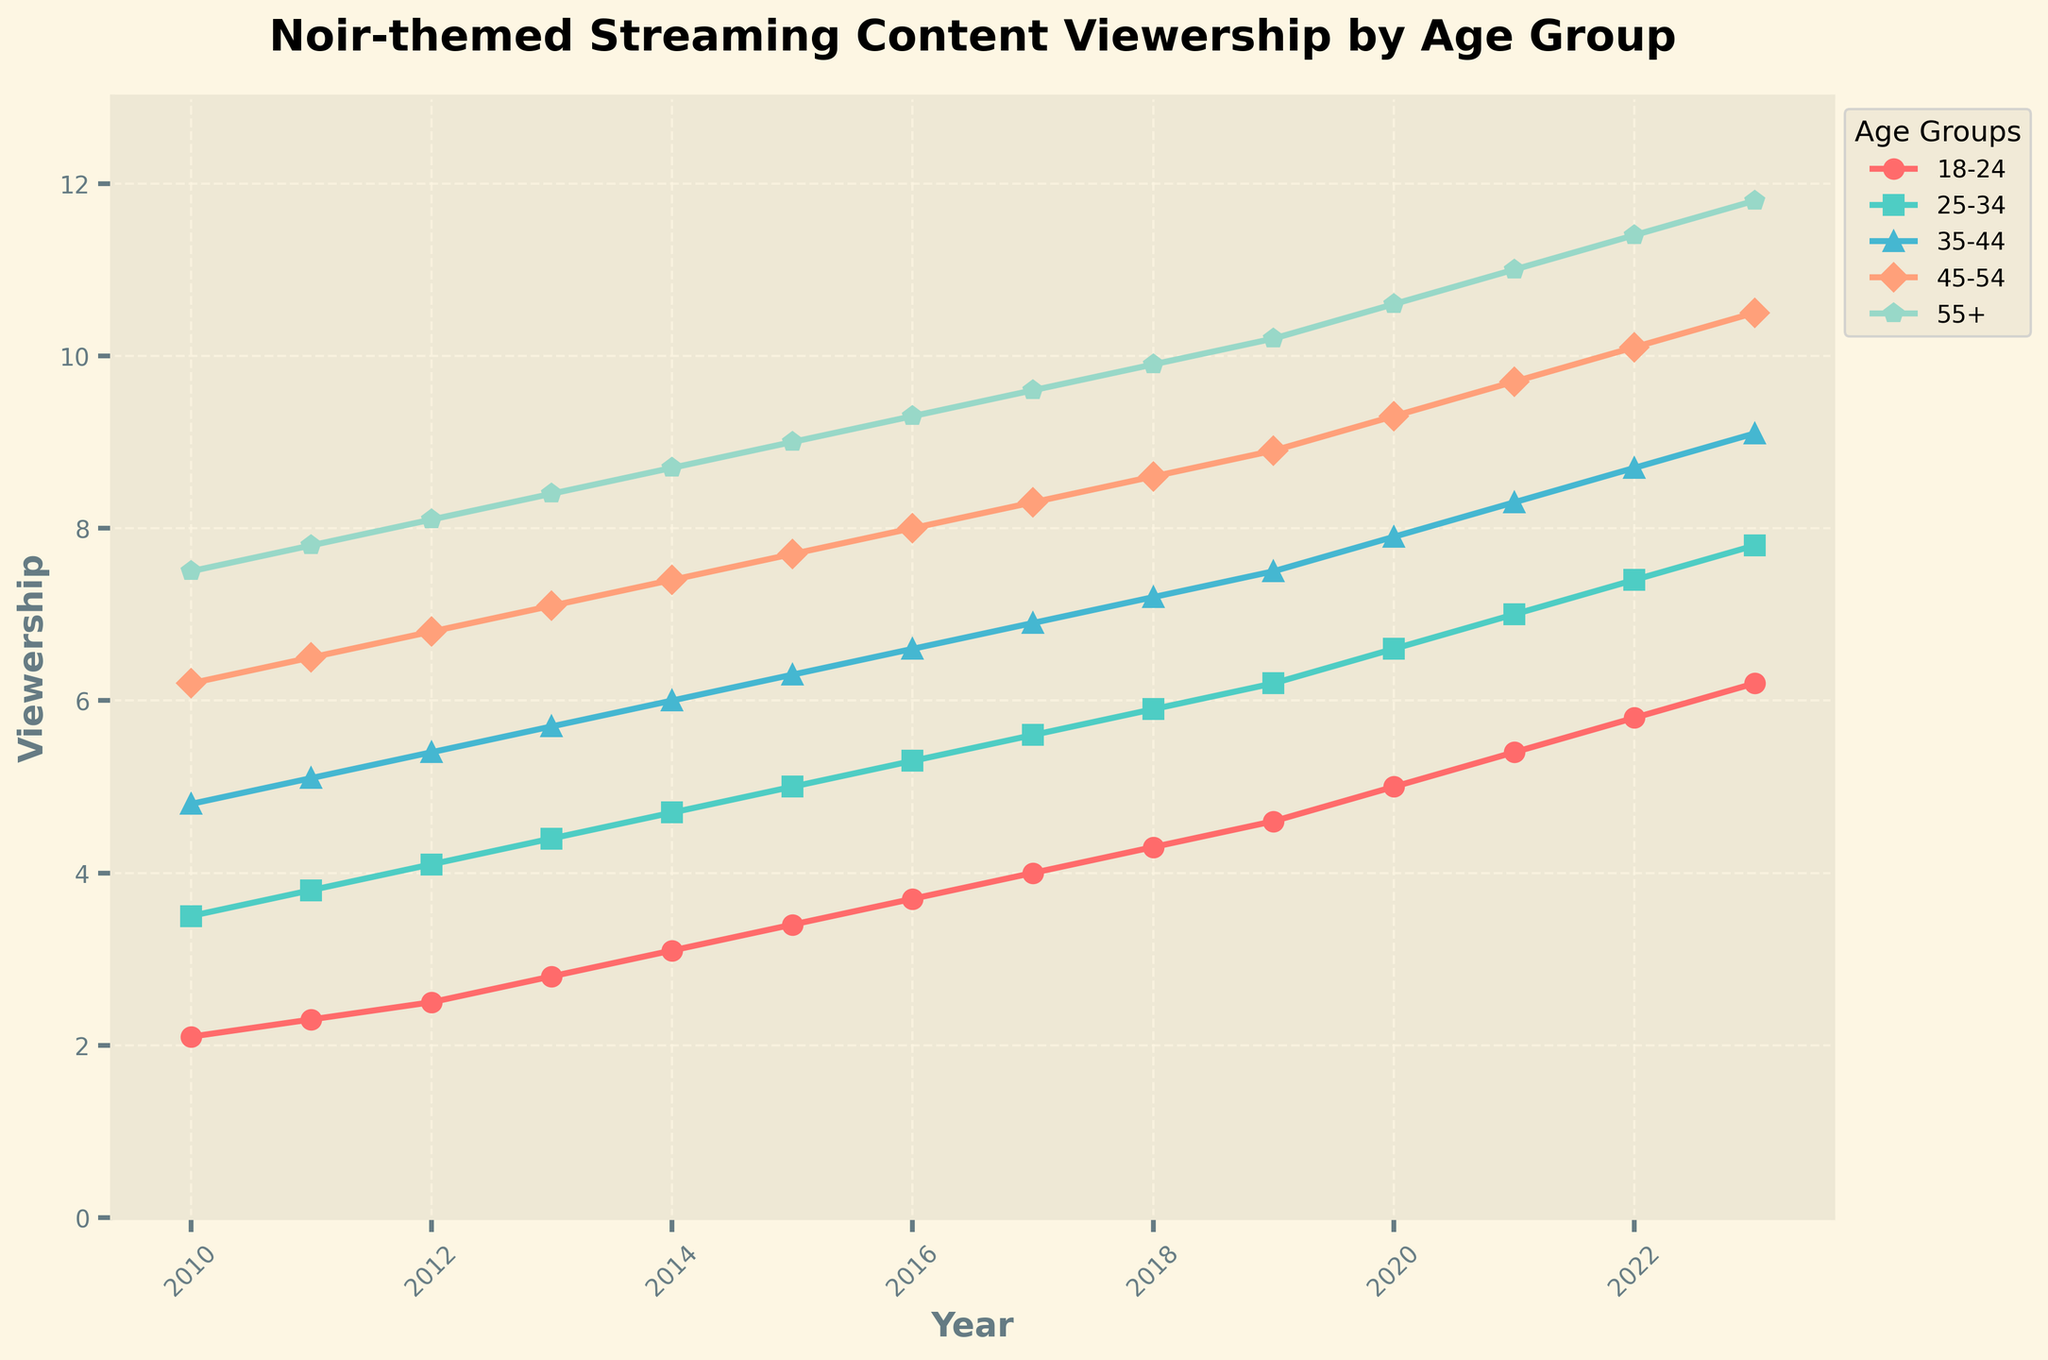What age group saw the greatest increase in viewership from 2018 to 2023? The viewership values for 2018 and 2023 are 4.3 and 6.2 (18-24), 5.9 and 7.8 (25-34), 7.2 and 9.1 (35-44), 8.6 and 10.5 (45-54), 9.9 and 11.8 (55+). The differences are 6.2 - 4.3 = 1.9, 7.8 - 5.9 = 1.9, 9.1 - 7.2 = 1.9, 10.5 - 8.6 = 1.9, 11.8 - 9.9 = 1.9. All groups saw the same increase.
Answer: All age groups saw equal increase Between which years did the 25-34 age group see the largest year-over-year increase? Examining the values for each year for the 25-34 age group: increases are 3.8 - 3.5 = 0.3, 4.1 - 3.8 = 0.3, 4.4 - 4.1 = 0.3, 4.7 - 4.4 = 0.3, 5 - 4.7 = 0.3, 5.3 - 5 = 0.3, 5.6 - 5.3 = 0.3, 5.9 - 5.6 = 0.3, 6.2 - 5.9 = 0.3, 6.6 - 6.2 = 0.4, 7 - 6.6 = 0.4, 7.4 - 7 = 0.4, 7.8 - 7.4 = 0.4. The increases are greatest between 2019-2020, 2020-2021, 2021-2022, and 2022-2023.
Answer: 2019-2020, 2020-2021, 2021-2022, 2022-2023 Which age group had the highest viewership in the year 2020? From the figure, the viewership values in 2020 are 5.0 (18-24), 6.6 (25-34), 7.9 (35-44), 9.3 (45-54), 10.6 (55+). The highest value is for the 55+ age group.
Answer: 55+ What was the trend in the viewership of the 45-54 age group from 2010 to 2023? Observe the viewership values for the 45-54 age group: 6.2, 6.5, 6.8, 7.1, 7.4, 7.7, 8.0, 8.3, 8.6, 8.9, 9.3, 9.7, 10.1, 10.5. The values consistently increase over the years, indicating an upward trend.
Answer: Upward Trend Calculate the average viewership for all age groups in 2015. The viewership values in 2015 for each age group are 3.4, 5.0, 6.3, 7.7, 9.0. The sum is 3.4 + 5.0 + 6.3 + 7.7 + 9.0 = 31.4. The average is 31.4 / 5 = 6.28.
Answer: 6.28 Which age group saw the least consistent growth trend from 2010 to 2023? Inspecting the figure's lines and looking for deviations or non-linear growth: all groups show a consistent upward trend, but some may not be perfectly linear. However, all trends appear reasonably consistent visually, without major irregularities.
Answer: All consistent During which year did the 18-24 age group surpass 4 units in viewership for the first time? The viewership values for the 18-24 age group are 2.1, 2.3, 2.5, 2.8, 3.1, 3.4, 3.7, 4.0, 4.3, 4.6, 5.0, 5.4, 5.8, 6.2 for years 2010 to 2023 respectively. The first value above 4 is in 2017.
Answer: 2017 